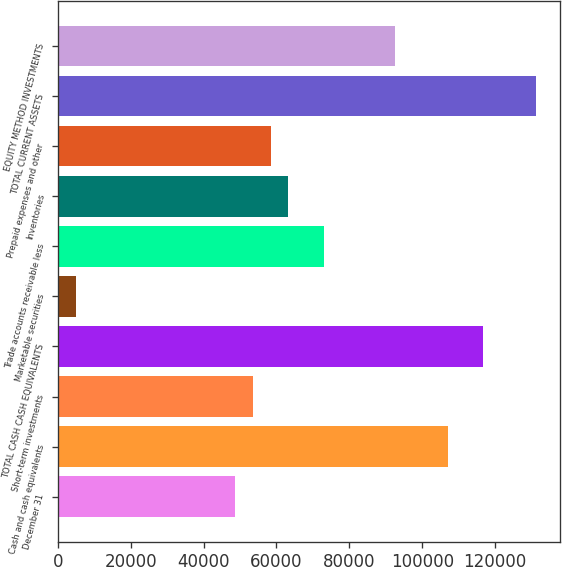Convert chart to OTSL. <chart><loc_0><loc_0><loc_500><loc_500><bar_chart><fcel>December 31<fcel>Cash and cash equivalents<fcel>Short-term investments<fcel>TOTAL CASH CASH EQUIVALENTS<fcel>Marketable securities<fcel>Trade accounts receivable less<fcel>Inventories<fcel>Prepaid expenses and other<fcel>TOTAL CURRENT ASSETS<fcel>EQUITY METHOD INVESTMENTS<nl><fcel>48671<fcel>107015<fcel>53533<fcel>116739<fcel>4913<fcel>72981<fcel>63257<fcel>58395<fcel>131325<fcel>92429<nl></chart> 